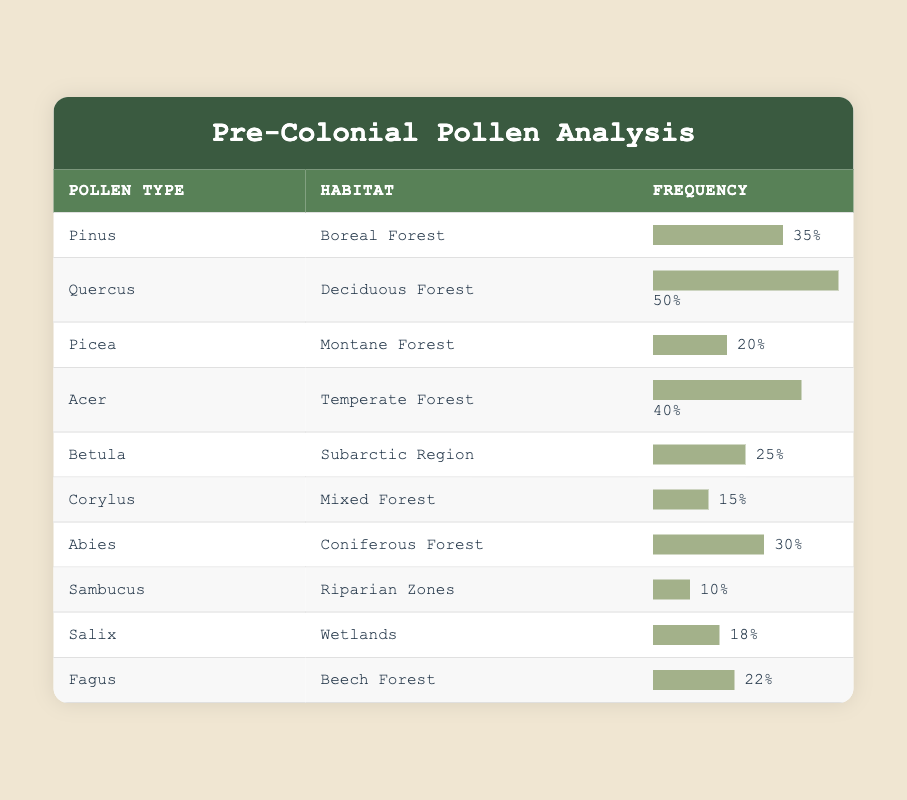What is the frequency of Quercus pollen in the Deciduous Forest? The table indicates that the frequency of Quercus pollen in the Deciduous Forest is listed next to it as 50.
Answer: 50 Which habitat has the highest frequency of pollen? By comparing the frequencies in the table, Quercus with a frequency of 50 has the highest frequency, as all other habitats have lower values.
Answer: Deciduous Forest Is Betula pollen associated with Wetlands? The table shows that Betula is associated with the Subarctic Region, not Wetlands. Therefore, the statement is false.
Answer: No How many pollen types have a frequency greater than 30? Reviewing the table, the following pollen types have frequencies higher than 30: Pinus (35), Quercus (50), Acer (40), Abies (30). Counting these yields a total of four.
Answer: 4 What is the average frequency of pollen types in the Coniferous Forest and Boreal Forest? The frequencies for Coniferous Forest (30) and Boreal Forest (35) are added together to get 65. Dividing by the number of habitats (2) gives an average of 65/2 = 32.5.
Answer: 32.5 Which habitat has the lowest overall pollen frequency? By scanning the frequencies, Sambucus in Riparian Zones has the lowest frequency at 10.
Answer: Riparian Zones How does the frequency of Salix pollen compare to the average of Fagus and Acer? The frequency of Salix is 18. The averages of Fagus (22) and Acer (40) total 62 and divide by 2 gives an average of 31. Since 18 is less than 31, Salix pollen's frequency is lower than the average of Fagus and Acer.
Answer: Lower What is the total frequency of all pollen types in the table? To find the total frequency, we add all the individual frequencies: (35 + 50 + 20 + 40 + 25 + 15 + 30 + 10 + 18 + 22) =  255.
Answer: 255 